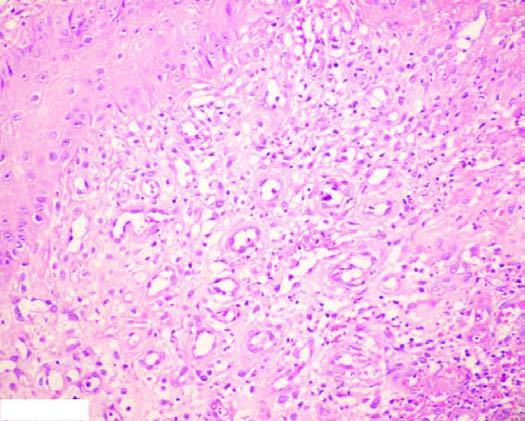does ctive granulation tissue have inflammatory cell infiltrate, newly formed blood vessels and young fibrous tissue in loose matrix?
Answer the question using a single word or phrase. Yes 